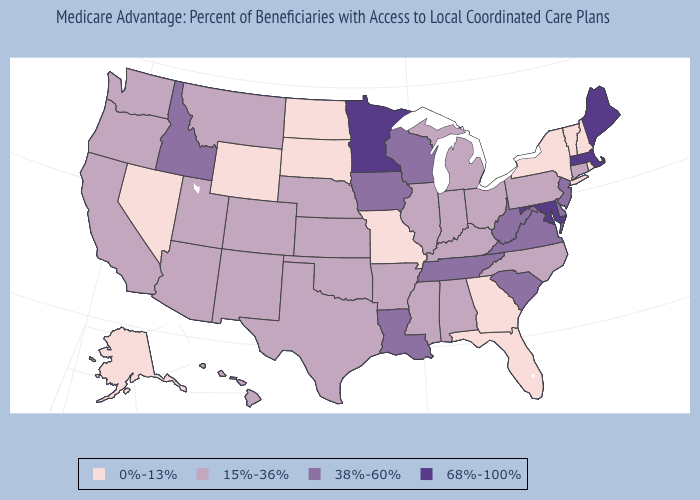Does Massachusetts have the highest value in the USA?
Concise answer only. Yes. Which states have the lowest value in the West?
Keep it brief. Alaska, Nevada, Wyoming. Does Kentucky have the highest value in the USA?
Short answer required. No. How many symbols are there in the legend?
Concise answer only. 4. Which states have the highest value in the USA?
Quick response, please. Massachusetts, Maryland, Maine, Minnesota. What is the lowest value in the West?
Concise answer only. 0%-13%. Is the legend a continuous bar?
Keep it brief. No. Name the states that have a value in the range 38%-60%?
Write a very short answer. Delaware, Iowa, Idaho, Louisiana, New Jersey, South Carolina, Tennessee, Virginia, Wisconsin, West Virginia. Does Kentucky have the highest value in the USA?
Be succinct. No. Does New York have the highest value in the USA?
Answer briefly. No. What is the value of Oklahoma?
Quick response, please. 15%-36%. Does Nevada have the same value as North Dakota?
Concise answer only. Yes. Does the first symbol in the legend represent the smallest category?
Short answer required. Yes. Which states have the lowest value in the USA?
Quick response, please. Alaska, Florida, Georgia, Missouri, North Dakota, New Hampshire, Nevada, New York, Rhode Island, South Dakota, Vermont, Wyoming. Name the states that have a value in the range 0%-13%?
Short answer required. Alaska, Florida, Georgia, Missouri, North Dakota, New Hampshire, Nevada, New York, Rhode Island, South Dakota, Vermont, Wyoming. 